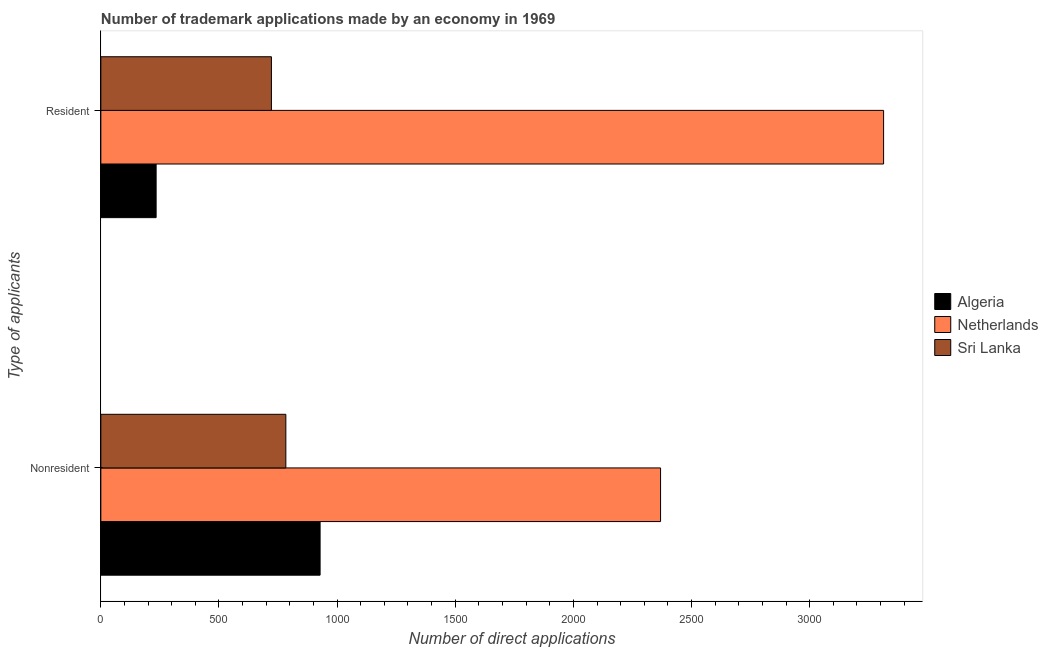How many different coloured bars are there?
Keep it short and to the point. 3. Are the number of bars per tick equal to the number of legend labels?
Give a very brief answer. Yes. How many bars are there on the 2nd tick from the top?
Make the answer very short. 3. How many bars are there on the 1st tick from the bottom?
Your response must be concise. 3. What is the label of the 2nd group of bars from the top?
Your answer should be compact. Nonresident. What is the number of trademark applications made by residents in Sri Lanka?
Ensure brevity in your answer.  722. Across all countries, what is the maximum number of trademark applications made by non residents?
Give a very brief answer. 2369. Across all countries, what is the minimum number of trademark applications made by residents?
Offer a terse response. 234. In which country was the number of trademark applications made by non residents maximum?
Your answer should be compact. Netherlands. In which country was the number of trademark applications made by non residents minimum?
Your response must be concise. Sri Lanka. What is the total number of trademark applications made by residents in the graph?
Give a very brief answer. 4269. What is the difference between the number of trademark applications made by residents in Algeria and that in Netherlands?
Give a very brief answer. -3079. What is the difference between the number of trademark applications made by non residents in Sri Lanka and the number of trademark applications made by residents in Netherlands?
Your answer should be very brief. -2530. What is the average number of trademark applications made by residents per country?
Give a very brief answer. 1423. What is the difference between the number of trademark applications made by residents and number of trademark applications made by non residents in Netherlands?
Make the answer very short. 944. In how many countries, is the number of trademark applications made by residents greater than 1700 ?
Your answer should be compact. 1. What is the ratio of the number of trademark applications made by non residents in Sri Lanka to that in Algeria?
Keep it short and to the point. 0.84. Is the number of trademark applications made by residents in Algeria less than that in Netherlands?
Provide a succinct answer. Yes. What does the 1st bar from the top in Resident represents?
Provide a short and direct response. Sri Lanka. What does the 3rd bar from the bottom in Nonresident represents?
Offer a terse response. Sri Lanka. How many bars are there?
Your answer should be compact. 6. Are all the bars in the graph horizontal?
Make the answer very short. Yes. Does the graph contain any zero values?
Make the answer very short. No. How are the legend labels stacked?
Offer a very short reply. Vertical. What is the title of the graph?
Your answer should be compact. Number of trademark applications made by an economy in 1969. What is the label or title of the X-axis?
Keep it short and to the point. Number of direct applications. What is the label or title of the Y-axis?
Provide a succinct answer. Type of applicants. What is the Number of direct applications of Algeria in Nonresident?
Keep it short and to the point. 928. What is the Number of direct applications in Netherlands in Nonresident?
Your answer should be compact. 2369. What is the Number of direct applications in Sri Lanka in Nonresident?
Your response must be concise. 783. What is the Number of direct applications of Algeria in Resident?
Ensure brevity in your answer.  234. What is the Number of direct applications in Netherlands in Resident?
Keep it short and to the point. 3313. What is the Number of direct applications of Sri Lanka in Resident?
Make the answer very short. 722. Across all Type of applicants, what is the maximum Number of direct applications of Algeria?
Ensure brevity in your answer.  928. Across all Type of applicants, what is the maximum Number of direct applications in Netherlands?
Your response must be concise. 3313. Across all Type of applicants, what is the maximum Number of direct applications in Sri Lanka?
Provide a succinct answer. 783. Across all Type of applicants, what is the minimum Number of direct applications in Algeria?
Provide a succinct answer. 234. Across all Type of applicants, what is the minimum Number of direct applications of Netherlands?
Your answer should be very brief. 2369. Across all Type of applicants, what is the minimum Number of direct applications of Sri Lanka?
Offer a very short reply. 722. What is the total Number of direct applications in Algeria in the graph?
Your response must be concise. 1162. What is the total Number of direct applications of Netherlands in the graph?
Offer a terse response. 5682. What is the total Number of direct applications of Sri Lanka in the graph?
Make the answer very short. 1505. What is the difference between the Number of direct applications of Algeria in Nonresident and that in Resident?
Provide a succinct answer. 694. What is the difference between the Number of direct applications of Netherlands in Nonresident and that in Resident?
Your answer should be very brief. -944. What is the difference between the Number of direct applications in Sri Lanka in Nonresident and that in Resident?
Offer a terse response. 61. What is the difference between the Number of direct applications in Algeria in Nonresident and the Number of direct applications in Netherlands in Resident?
Provide a succinct answer. -2385. What is the difference between the Number of direct applications of Algeria in Nonresident and the Number of direct applications of Sri Lanka in Resident?
Provide a succinct answer. 206. What is the difference between the Number of direct applications of Netherlands in Nonresident and the Number of direct applications of Sri Lanka in Resident?
Your answer should be very brief. 1647. What is the average Number of direct applications of Algeria per Type of applicants?
Provide a succinct answer. 581. What is the average Number of direct applications in Netherlands per Type of applicants?
Provide a succinct answer. 2841. What is the average Number of direct applications of Sri Lanka per Type of applicants?
Your response must be concise. 752.5. What is the difference between the Number of direct applications in Algeria and Number of direct applications in Netherlands in Nonresident?
Your answer should be very brief. -1441. What is the difference between the Number of direct applications of Algeria and Number of direct applications of Sri Lanka in Nonresident?
Offer a terse response. 145. What is the difference between the Number of direct applications of Netherlands and Number of direct applications of Sri Lanka in Nonresident?
Make the answer very short. 1586. What is the difference between the Number of direct applications of Algeria and Number of direct applications of Netherlands in Resident?
Your response must be concise. -3079. What is the difference between the Number of direct applications of Algeria and Number of direct applications of Sri Lanka in Resident?
Your response must be concise. -488. What is the difference between the Number of direct applications of Netherlands and Number of direct applications of Sri Lanka in Resident?
Offer a very short reply. 2591. What is the ratio of the Number of direct applications in Algeria in Nonresident to that in Resident?
Offer a very short reply. 3.97. What is the ratio of the Number of direct applications in Netherlands in Nonresident to that in Resident?
Offer a very short reply. 0.72. What is the ratio of the Number of direct applications in Sri Lanka in Nonresident to that in Resident?
Provide a short and direct response. 1.08. What is the difference between the highest and the second highest Number of direct applications in Algeria?
Keep it short and to the point. 694. What is the difference between the highest and the second highest Number of direct applications of Netherlands?
Your answer should be very brief. 944. What is the difference between the highest and the lowest Number of direct applications in Algeria?
Keep it short and to the point. 694. What is the difference between the highest and the lowest Number of direct applications in Netherlands?
Give a very brief answer. 944. 